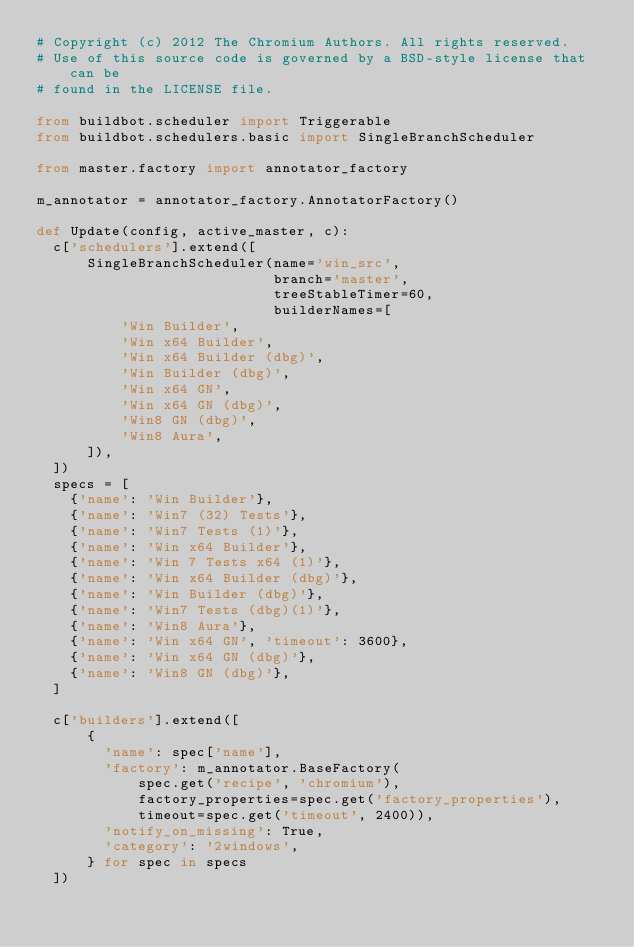<code> <loc_0><loc_0><loc_500><loc_500><_Python_># Copyright (c) 2012 The Chromium Authors. All rights reserved.
# Use of this source code is governed by a BSD-style license that can be
# found in the LICENSE file.

from buildbot.scheduler import Triggerable
from buildbot.schedulers.basic import SingleBranchScheduler

from master.factory import annotator_factory

m_annotator = annotator_factory.AnnotatorFactory()

def Update(config, active_master, c):
  c['schedulers'].extend([
      SingleBranchScheduler(name='win_src',
                            branch='master',
                            treeStableTimer=60,
                            builderNames=[
          'Win Builder',
          'Win x64 Builder',
          'Win x64 Builder (dbg)',
          'Win Builder (dbg)',
          'Win x64 GN',
          'Win x64 GN (dbg)',
          'Win8 GN (dbg)',
          'Win8 Aura',
      ]),
  ])
  specs = [
    {'name': 'Win Builder'},
    {'name': 'Win7 (32) Tests'},
    {'name': 'Win7 Tests (1)'},
    {'name': 'Win x64 Builder'},
    {'name': 'Win 7 Tests x64 (1)'},
    {'name': 'Win x64 Builder (dbg)'},
    {'name': 'Win Builder (dbg)'},
    {'name': 'Win7 Tests (dbg)(1)'},
    {'name': 'Win8 Aura'},
    {'name': 'Win x64 GN', 'timeout': 3600},
    {'name': 'Win x64 GN (dbg)'},
    {'name': 'Win8 GN (dbg)'},
  ]

  c['builders'].extend([
      {
        'name': spec['name'],
        'factory': m_annotator.BaseFactory(
            spec.get('recipe', 'chromium'),
            factory_properties=spec.get('factory_properties'),
            timeout=spec.get('timeout', 2400)),
        'notify_on_missing': True,
        'category': '2windows',
      } for spec in specs
  ])
</code> 